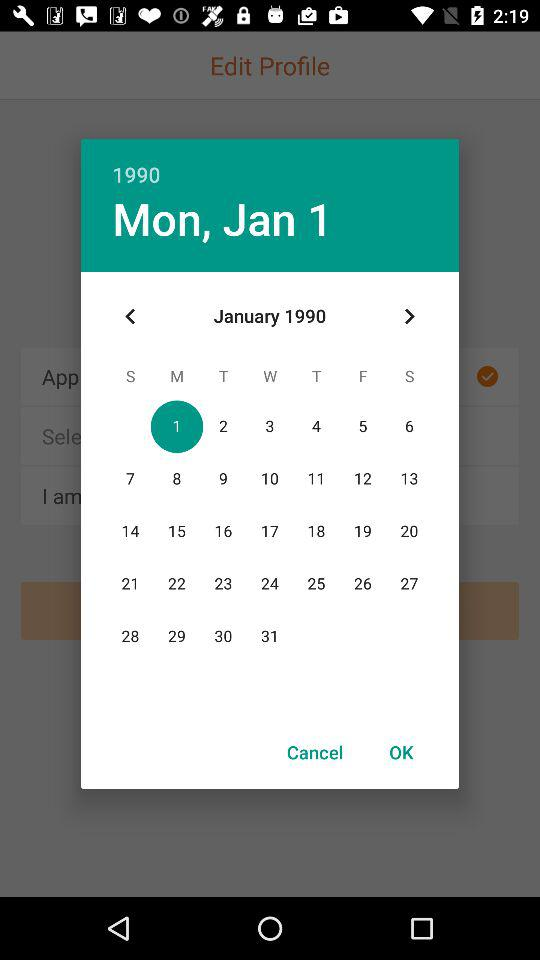Which year is shown on the calendar? The shown year is 1990. 